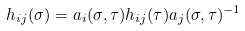Convert formula to latex. <formula><loc_0><loc_0><loc_500><loc_500>h _ { i j } ( \sigma ) = a _ { i } ( \sigma , \tau ) h _ { i j } ( \tau ) a _ { j } ( \sigma , \tau ) ^ { - 1 }</formula> 